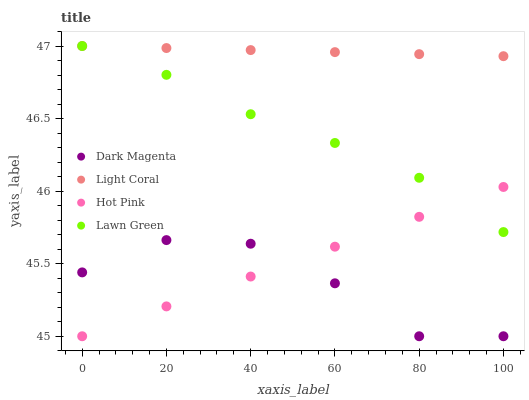Does Dark Magenta have the minimum area under the curve?
Answer yes or no. Yes. Does Light Coral have the maximum area under the curve?
Answer yes or no. Yes. Does Lawn Green have the minimum area under the curve?
Answer yes or no. No. Does Lawn Green have the maximum area under the curve?
Answer yes or no. No. Is Light Coral the smoothest?
Answer yes or no. Yes. Is Dark Magenta the roughest?
Answer yes or no. Yes. Is Lawn Green the smoothest?
Answer yes or no. No. Is Lawn Green the roughest?
Answer yes or no. No. Does Hot Pink have the lowest value?
Answer yes or no. Yes. Does Lawn Green have the lowest value?
Answer yes or no. No. Does Lawn Green have the highest value?
Answer yes or no. Yes. Does Hot Pink have the highest value?
Answer yes or no. No. Is Dark Magenta less than Light Coral?
Answer yes or no. Yes. Is Lawn Green greater than Dark Magenta?
Answer yes or no. Yes. Does Lawn Green intersect Hot Pink?
Answer yes or no. Yes. Is Lawn Green less than Hot Pink?
Answer yes or no. No. Is Lawn Green greater than Hot Pink?
Answer yes or no. No. Does Dark Magenta intersect Light Coral?
Answer yes or no. No. 